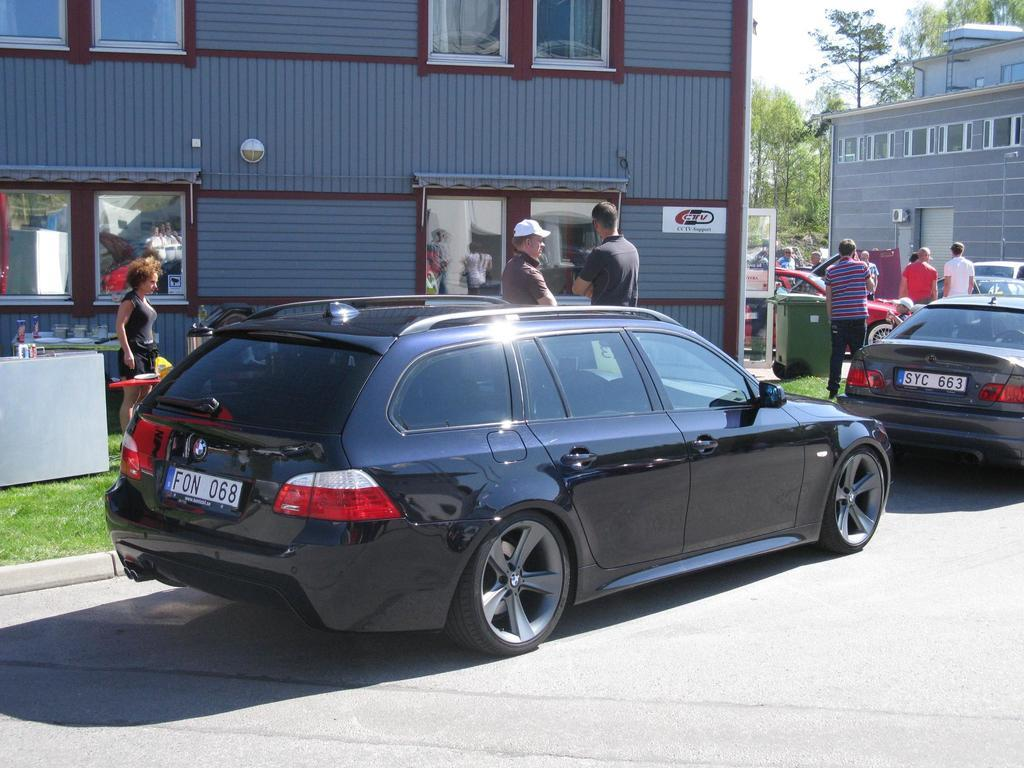<image>
Give a short and clear explanation of the subsequent image. A black vehicle with the license plate number F0N 068 is parked on the street. 